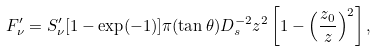<formula> <loc_0><loc_0><loc_500><loc_500>F ^ { \prime } _ { \nu } = S ^ { \prime } _ { \nu } [ 1 - \exp ( - 1 ) ] \pi ( \tan \theta ) D _ { s } ^ { - 2 } z ^ { 2 } \left [ 1 - \left ( \frac { z _ { 0 } } { z } \right ) ^ { 2 } \right ] ,</formula> 